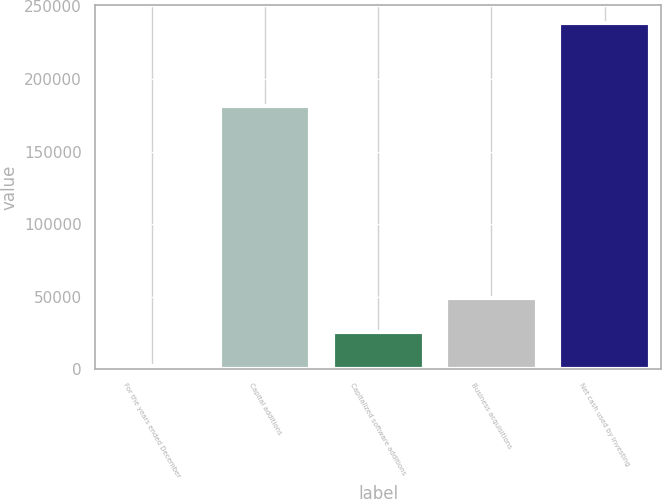Convert chart. <chart><loc_0><loc_0><loc_500><loc_500><bar_chart><fcel>For the years ended December<fcel>Capital additions<fcel>Capitalized software additions<fcel>Business acquisitions<fcel>Net cash used by investing<nl><fcel>2005<fcel>181069<fcel>25671.1<fcel>49337.2<fcel>238666<nl></chart> 